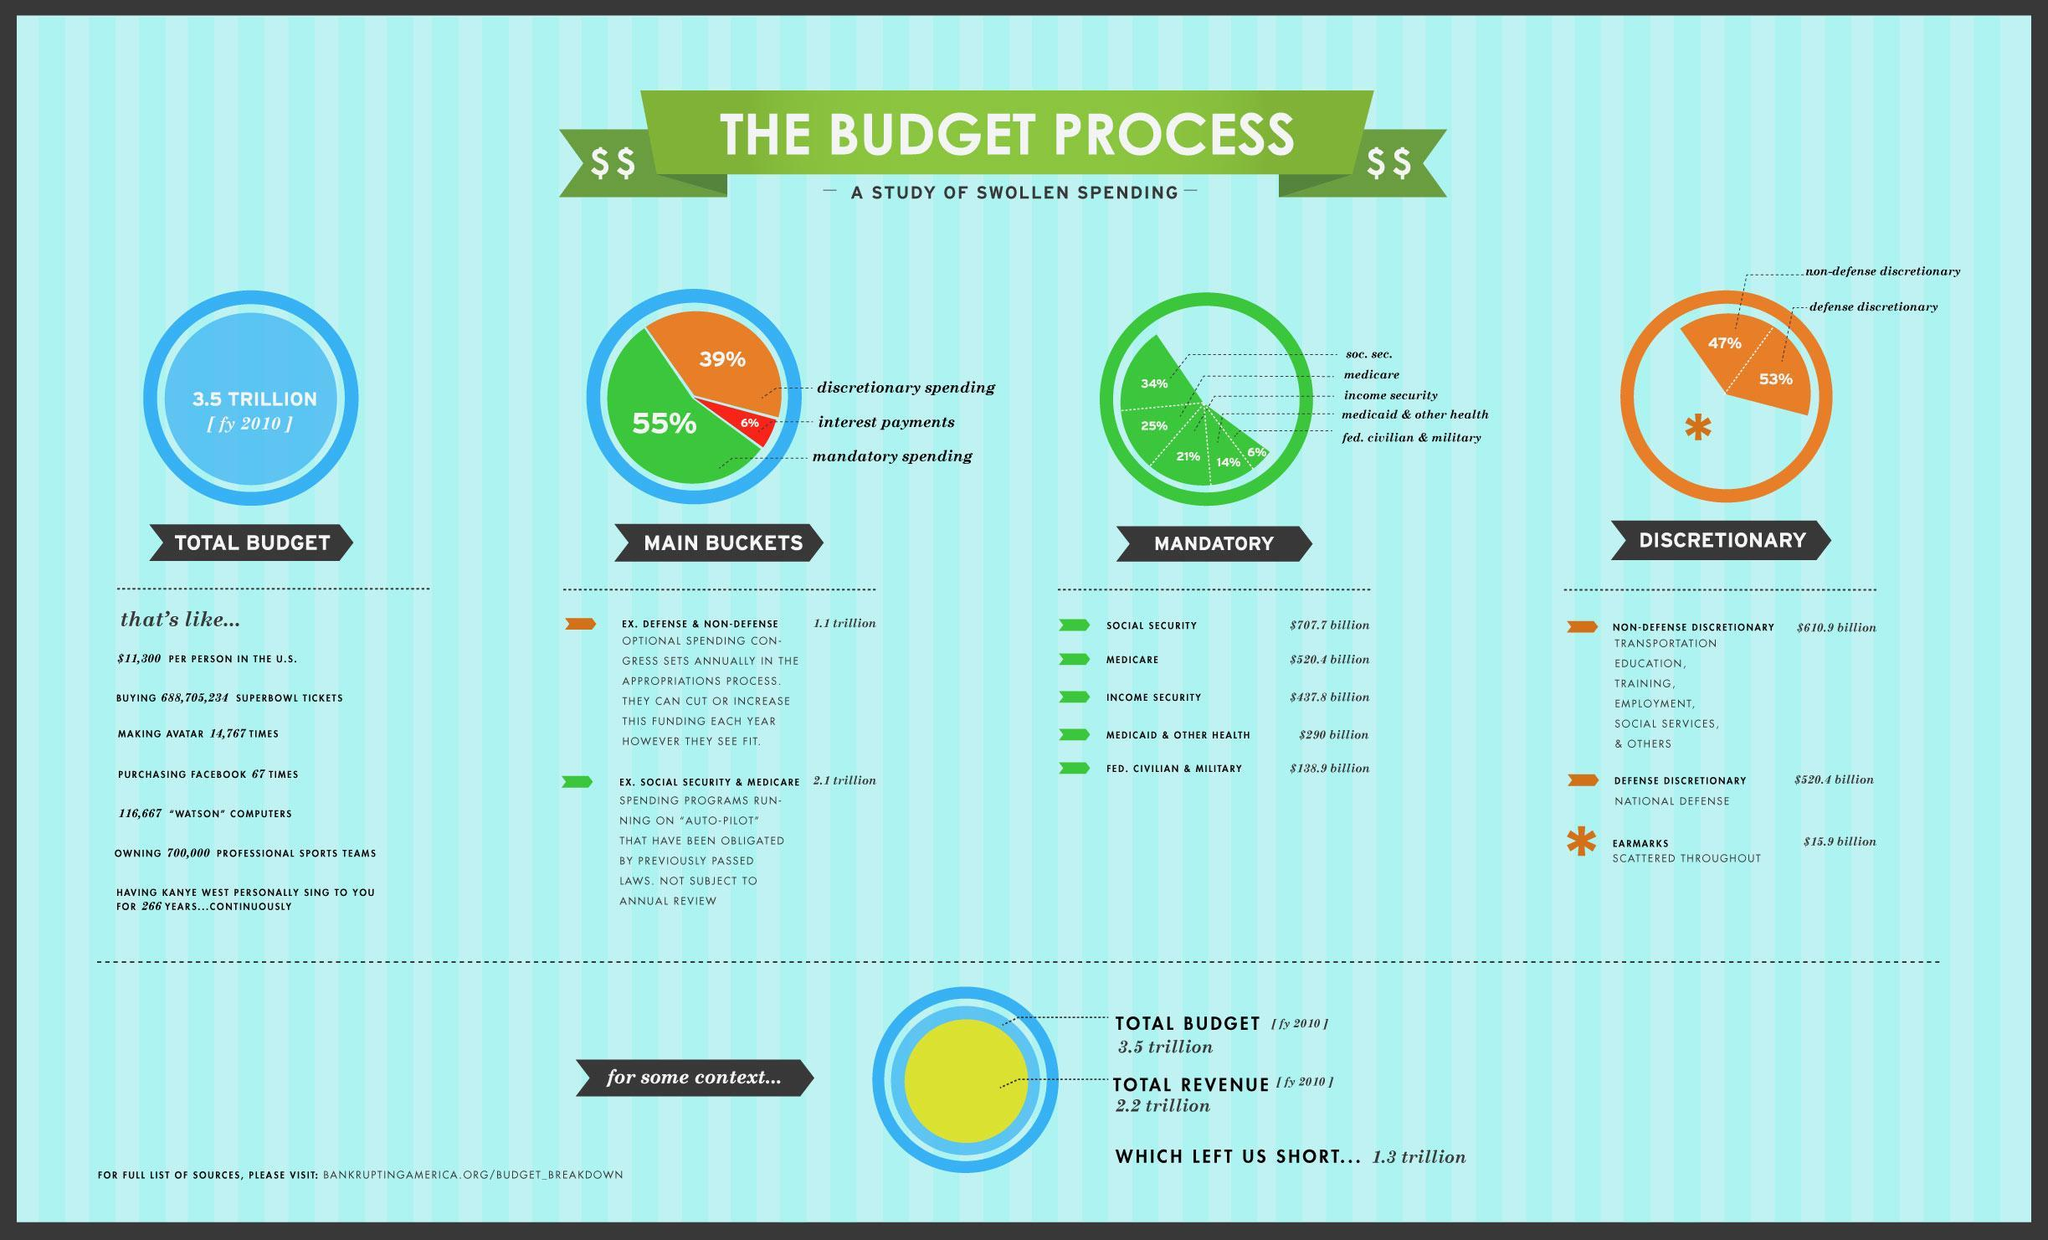Which one gets the lowest amount among the 5 sectors listed under the mandatory spending?
Answer the question with a short phrase. Fed. Civilian and military What color represents discretionary expenditure in the pie charts given in the infographic, orange, green or blue? orange What percentage of discretionary spending does the defense discretionary get? 53% What color represents mandatory expenditure in the pie charts given in the infographic, orange, green or blue? green How much money in dollars was allotted for interest payments in the fiscal year 2010? .3 trillion What is the difference in Total budget and total revenue in the fiscal year 2010? 1.3 trillion Which one gets the highest amount under the discretionary spending? Non-defense discretionary What payment does not come under discretionary or mandatory expenditures? Interest payments How many sectors that are funded under mandatory expenditures are listed in the infographic? 5 Which one gets the highest amount under the mandatory spending? social security 